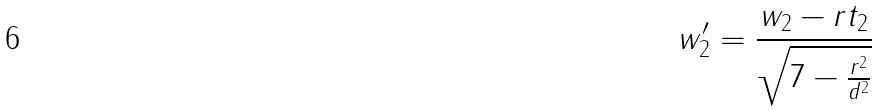Convert formula to latex. <formula><loc_0><loc_0><loc_500><loc_500>w _ { 2 } ^ { \prime } = \frac { w _ { 2 } - r t _ { 2 } } { \sqrt { 7 - \frac { r ^ { 2 } } { d ^ { 2 } } } }</formula> 